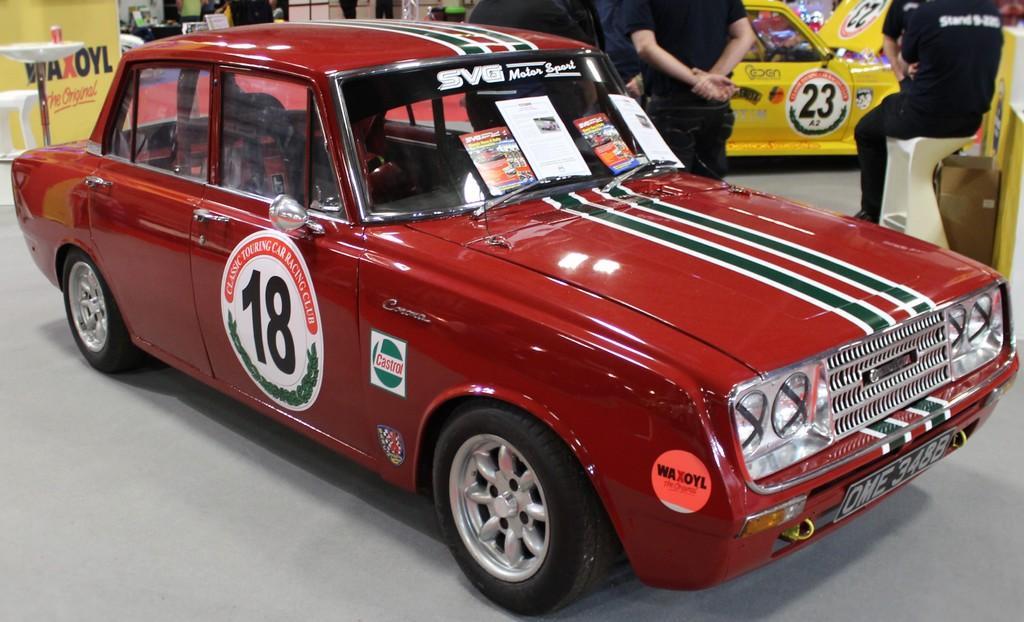Describe this image in one or two sentences. In the image we can see vehicles, these are the headlights and number plate of the vehicle. This is a floor, we can see there are even people wearing clothes. 